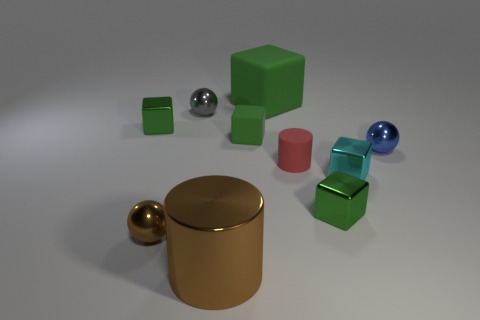Subtract all green cylinders. How many green blocks are left? 4 Subtract all large green rubber cubes. How many cubes are left? 4 Subtract all cyan cubes. How many cubes are left? 4 Subtract all blue spheres. Subtract all green blocks. How many spheres are left? 2 Subtract all balls. How many objects are left? 7 Subtract 1 brown cylinders. How many objects are left? 9 Subtract all big brown rubber objects. Subtract all cyan shiny blocks. How many objects are left? 9 Add 7 small gray spheres. How many small gray spheres are left? 8 Add 9 tiny brown matte cubes. How many tiny brown matte cubes exist? 9 